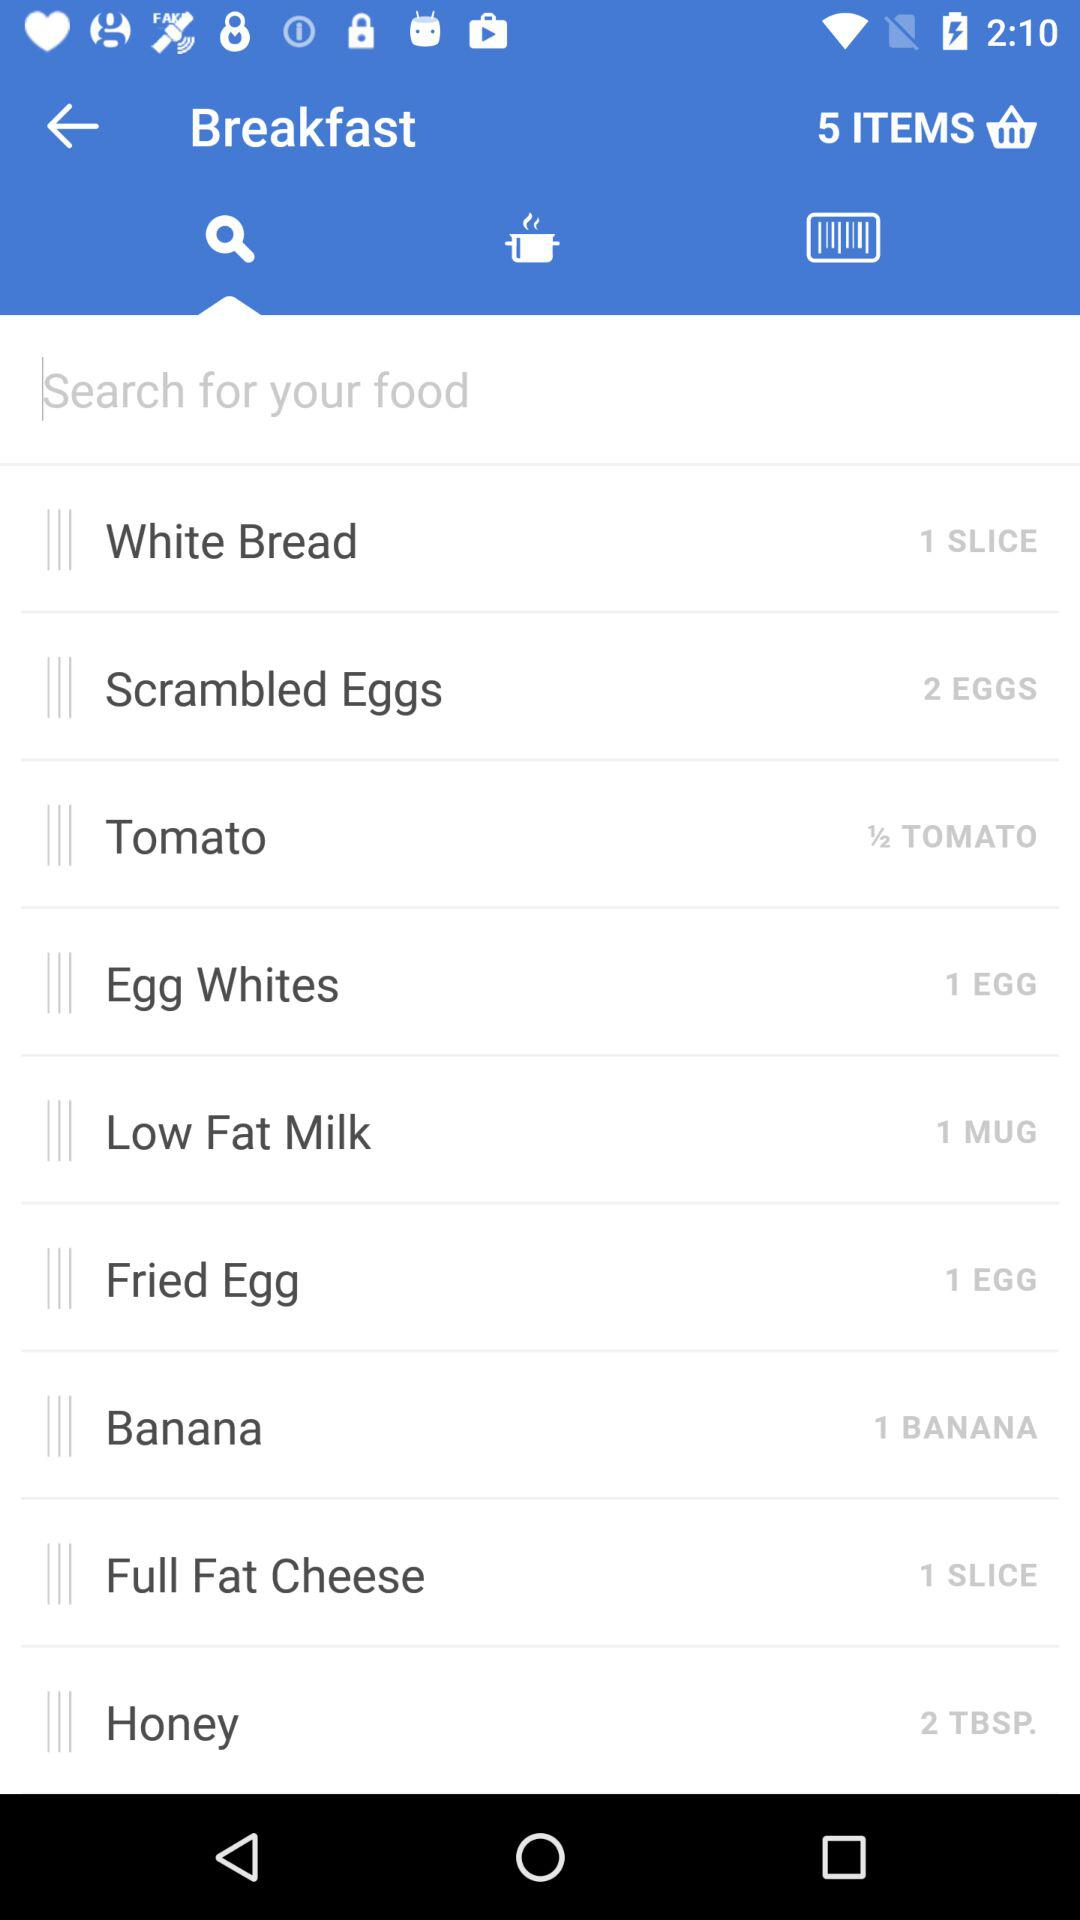How many mugs of low-fat milk are shown here? The number of mugs is 1. 